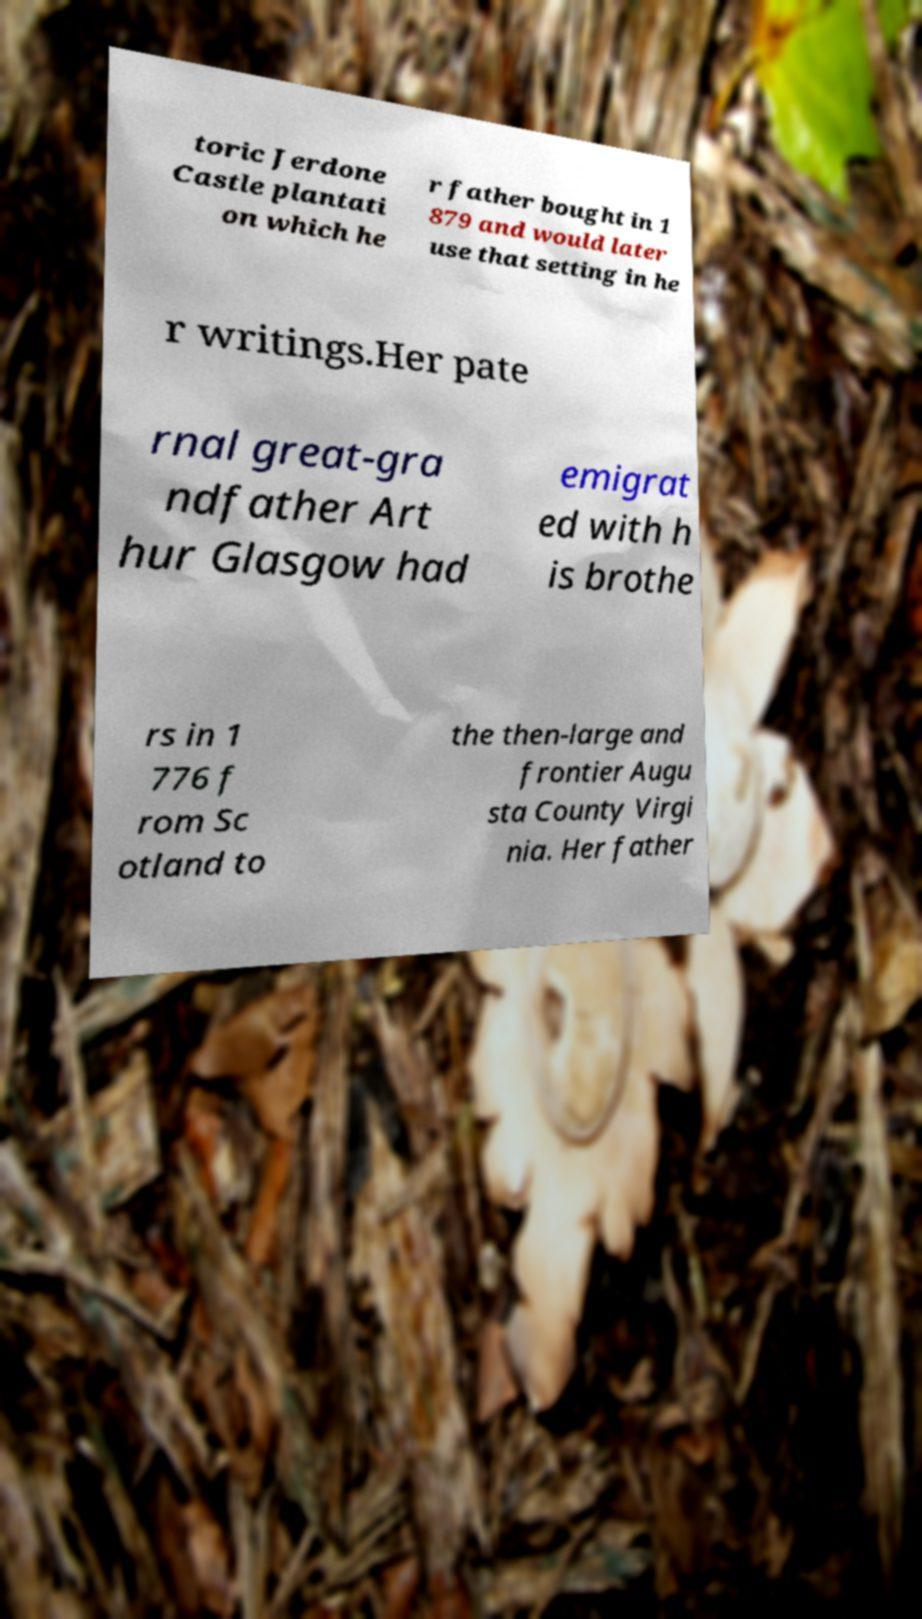Please identify and transcribe the text found in this image. toric Jerdone Castle plantati on which he r father bought in 1 879 and would later use that setting in he r writings.Her pate rnal great-gra ndfather Art hur Glasgow had emigrat ed with h is brothe rs in 1 776 f rom Sc otland to the then-large and frontier Augu sta County Virgi nia. Her father 